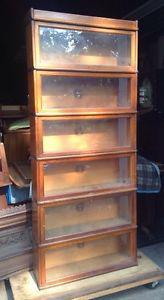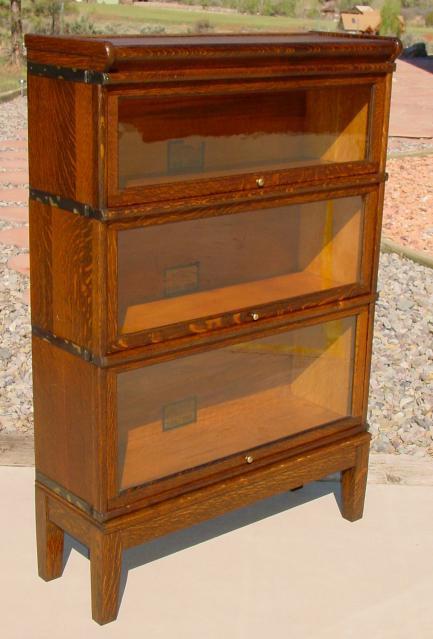The first image is the image on the left, the second image is the image on the right. For the images displayed, is the sentence "One of the photos shows a wooden bookcase with at most three shelves." factually correct? Answer yes or no. Yes. The first image is the image on the left, the second image is the image on the right. Given the left and right images, does the statement "there is a book case, outdoors with 3 shelves" hold true? Answer yes or no. Yes. 